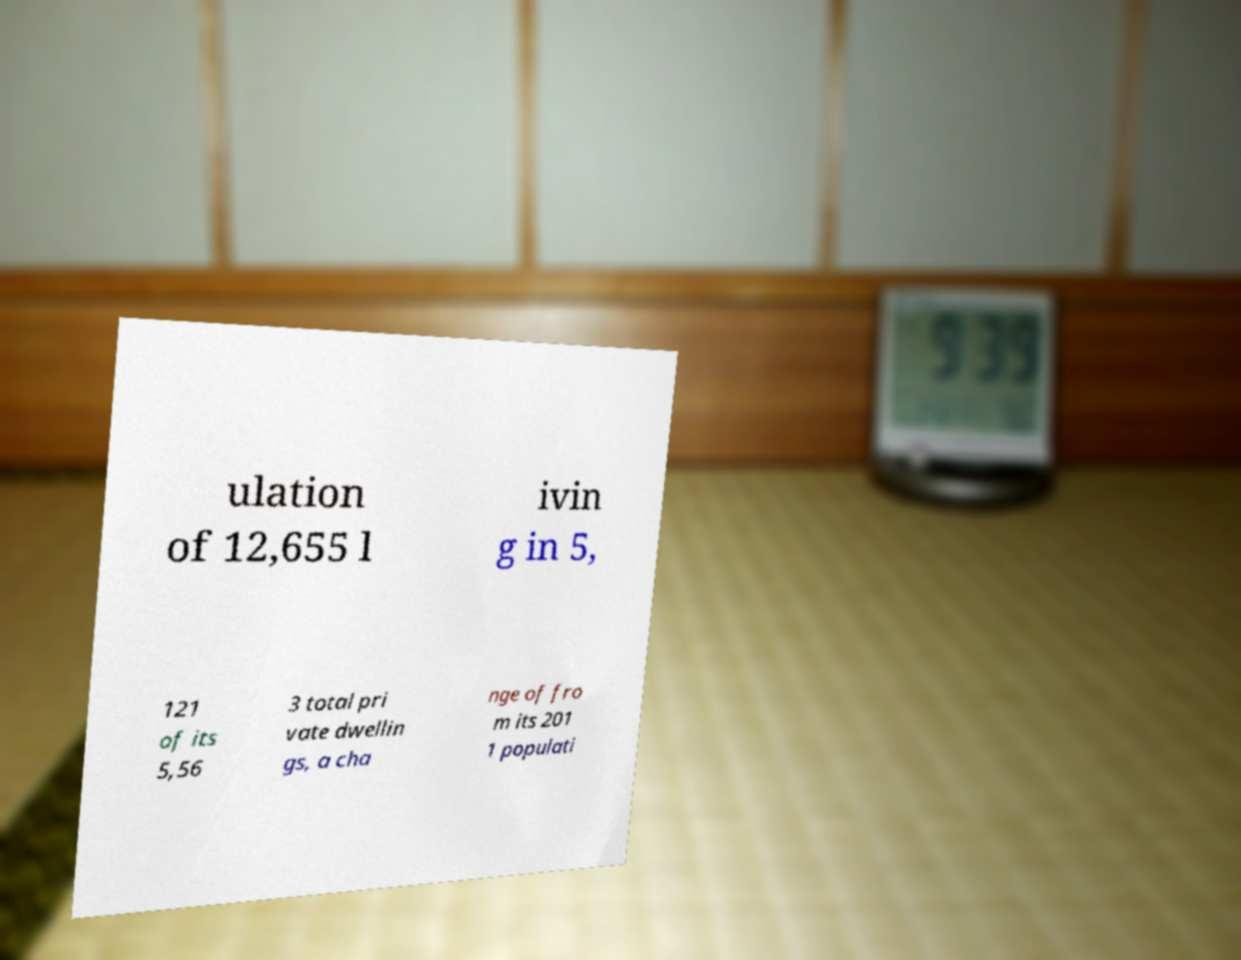For documentation purposes, I need the text within this image transcribed. Could you provide that? ulation of 12,655 l ivin g in 5, 121 of its 5,56 3 total pri vate dwellin gs, a cha nge of fro m its 201 1 populati 